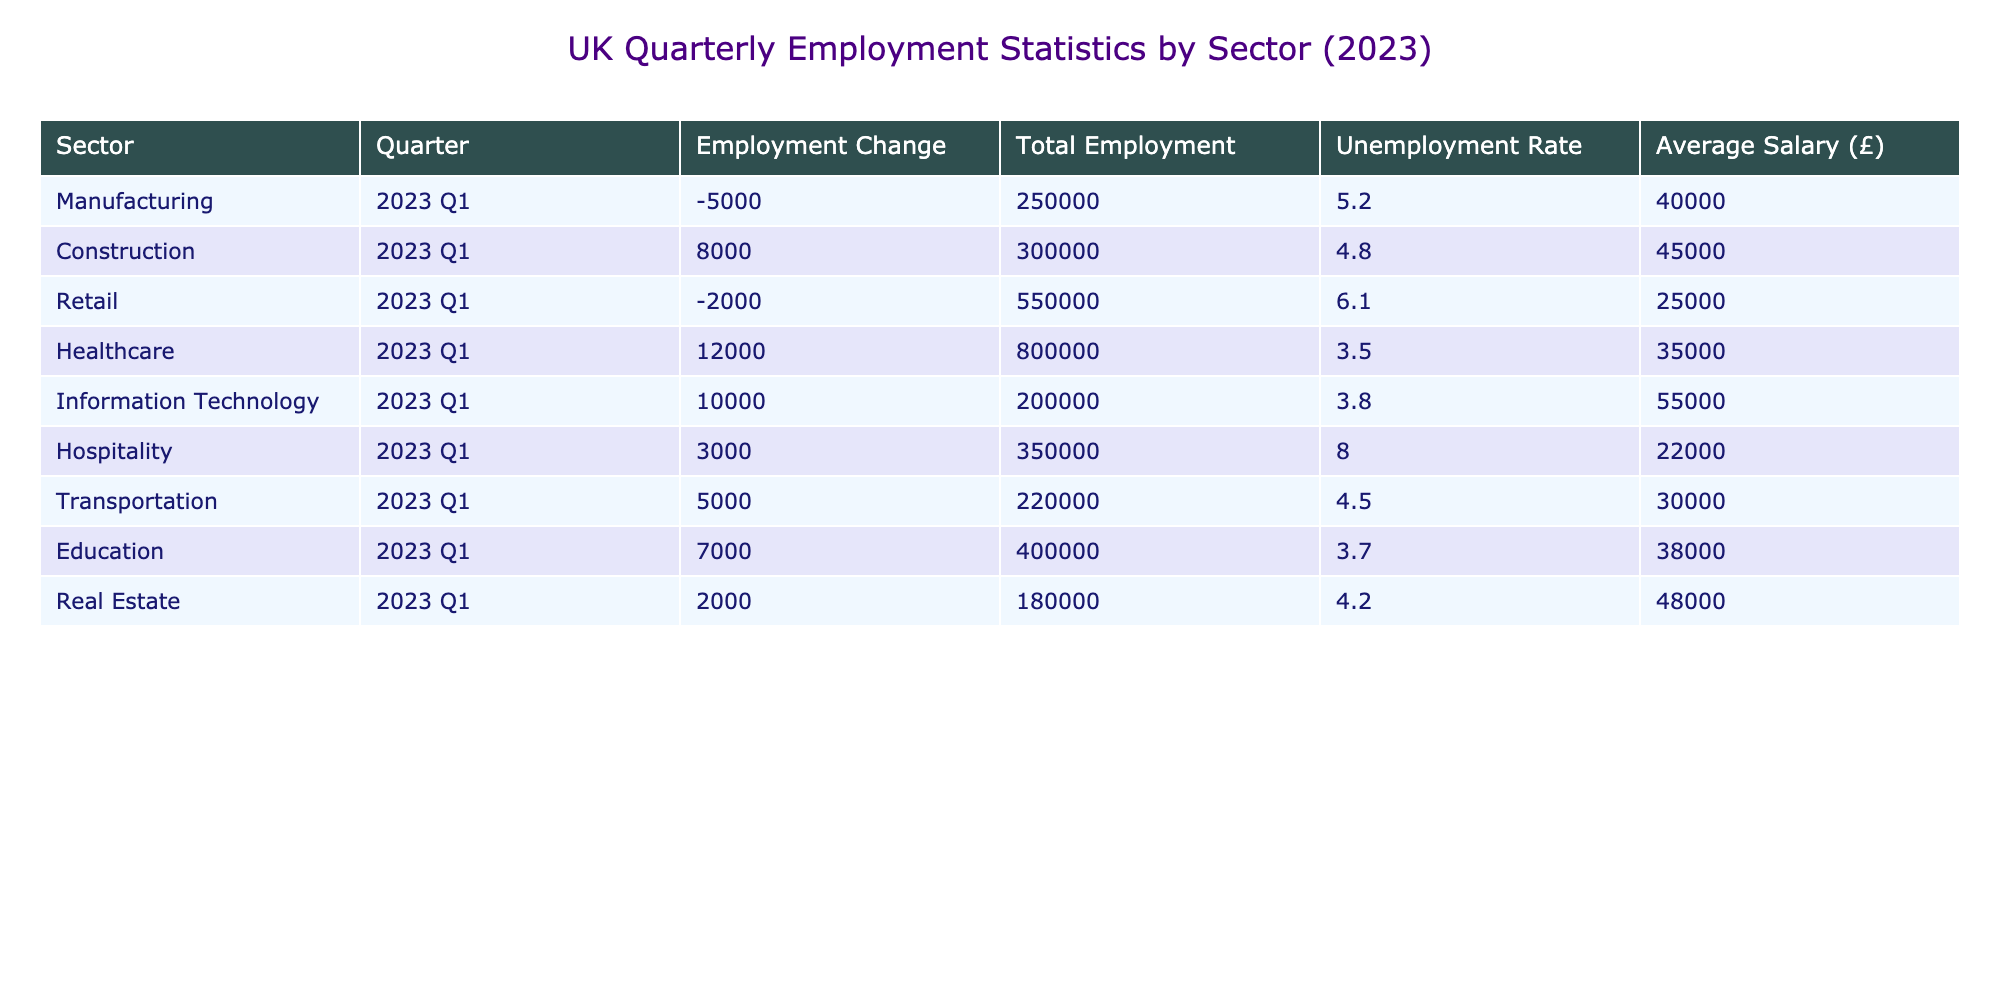What sector experienced the largest employment change in 2023 Q1? By reviewing the 'Employment Change' column, we can see that 'Healthcare' has the highest value with an increase of 12000 jobs.
Answer: Healthcare What was the total employment in the Retail sector for 2023 Q1? Referring to the 'Total Employment' column for the 'Retail' sector, the value listed is 550000.
Answer: 550000 Did the Transportation sector have a positive employment change in 2023 Q1? Looking at the 'Employment Change' for 'Transportation', the value is 5000, which is positive. Thus, the answer is yes.
Answer: Yes What was the average salary across the Construction and Manufacturing sectors? First, we take the salaries from both sectors: Construction (£45000) and Manufacturing (£40000). Adding these gives us £45000 + £40000 = £85000. Then divide by 2 to find the average: £85000 / 2 = £42500.
Answer: 42500 Which sector had the lowest unemployment rate in 2023 Q1? By inspecting the 'Unemployment Rate' column, we find that 'Healthcare' has the lowest unemployment rate at 3.5%.
Answer: Healthcare What is the difference in total employment between the Hospitality and Information Technology sectors? The total employment in Hospitality is 350000 and in Information Technology is 200000. Subtracting these gives us 350000 - 200000 = 150000.
Answer: 150000 Is the average salary in the Healthcare sector higher than that in the Retail sector? The average salary in Healthcare is £35000, while in Retail it is £25000. Comparing these shows that £35000 is indeed higher than £25000, so the answer is yes.
Answer: Yes What was the total employment for all sectors combined in 2023 Q1? We sum the total employment for all sectors: 250000 (Manufacturing) + 300000 (Construction) + 550000 (Retail) + 800000 (Healthcare) + 200000 (Information Technology) + 350000 (Hospitality) + 220000 (Transportation) + 400000 (Education) + 180000 (Real Estate) = 2850000. Thus, the total is 2850000.
Answer: 2850000 Which two sectors had a combined employment change of more than 10000? We look for combinations of sectors. The 'Healthcare' sector increased by 12000 and 'Information Technology' increased by 10000. Combined, they total 22000, which exceeds 10000. Hence, the answer is yes for these two sectors.
Answer: Yes 